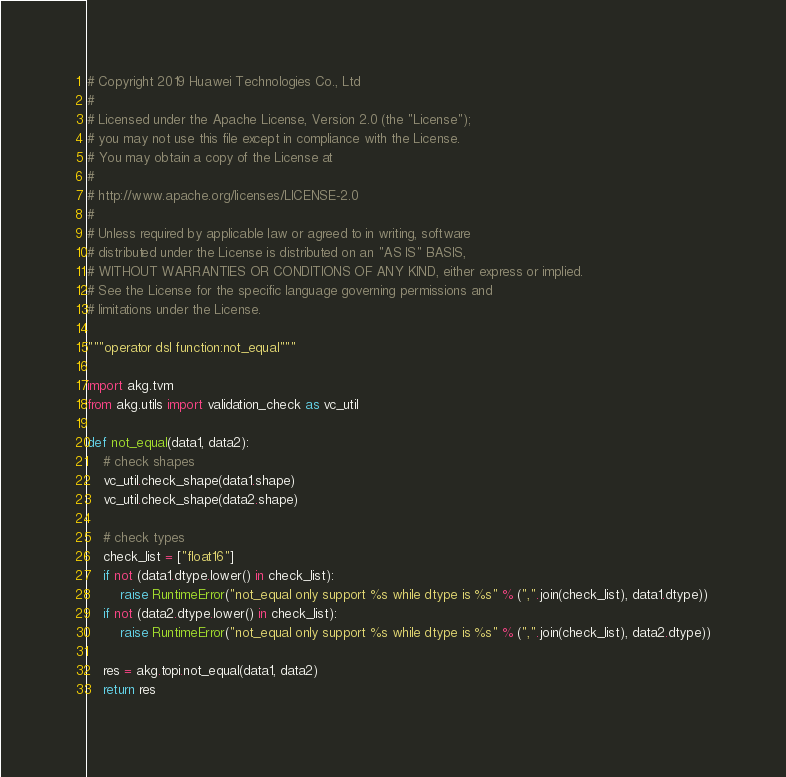<code> <loc_0><loc_0><loc_500><loc_500><_Python_># Copyright 2019 Huawei Technologies Co., Ltd
#
# Licensed under the Apache License, Version 2.0 (the "License");
# you may not use this file except in compliance with the License.
# You may obtain a copy of the License at
#
# http://www.apache.org/licenses/LICENSE-2.0
#
# Unless required by applicable law or agreed to in writing, software
# distributed under the License is distributed on an "AS IS" BASIS,
# WITHOUT WARRANTIES OR CONDITIONS OF ANY KIND, either express or implied.
# See the License for the specific language governing permissions and
# limitations under the License.

"""operator dsl function:not_equal"""

import akg.tvm
from akg.utils import validation_check as vc_util

def not_equal(data1, data2):
    # check shapes
    vc_util.check_shape(data1.shape)
    vc_util.check_shape(data2.shape)

    # check types
    check_list = ["float16"]
    if not (data1.dtype.lower() in check_list):
        raise RuntimeError("not_equal only support %s while dtype is %s" % (",".join(check_list), data1.dtype))
    if not (data2.dtype.lower() in check_list):
        raise RuntimeError("not_equal only support %s while dtype is %s" % (",".join(check_list), data2.dtype))

    res = akg.topi.not_equal(data1, data2)
    return res
</code> 